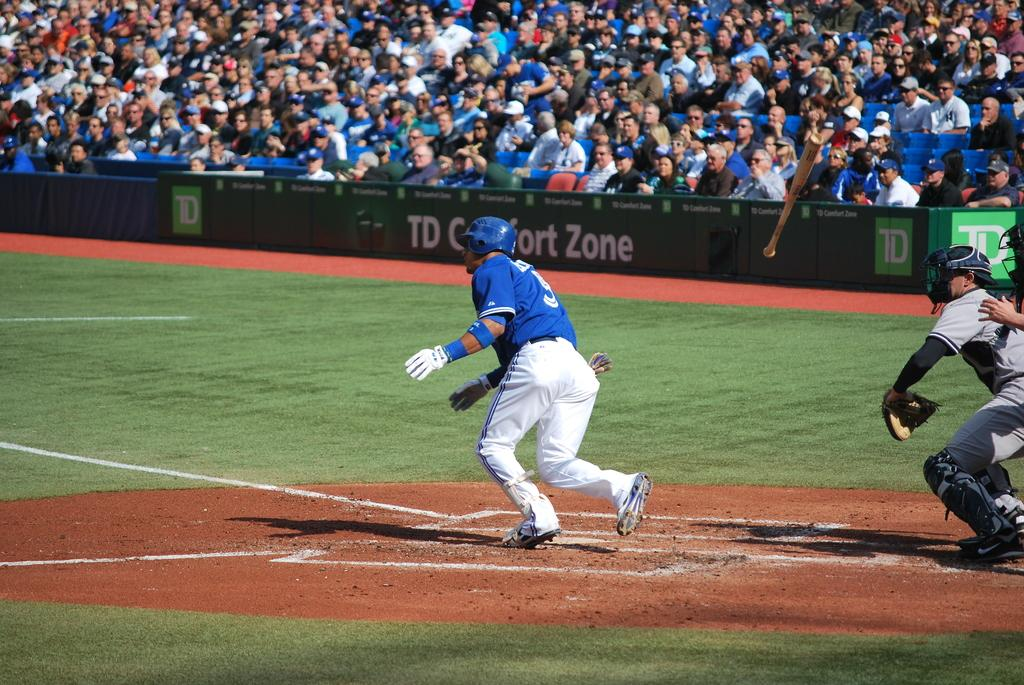<image>
Offer a succinct explanation of the picture presented. Player number 5 heads to first base after recording a hit during a baseball game with fans behind a TD Comfort Zone banner cheering him on. 